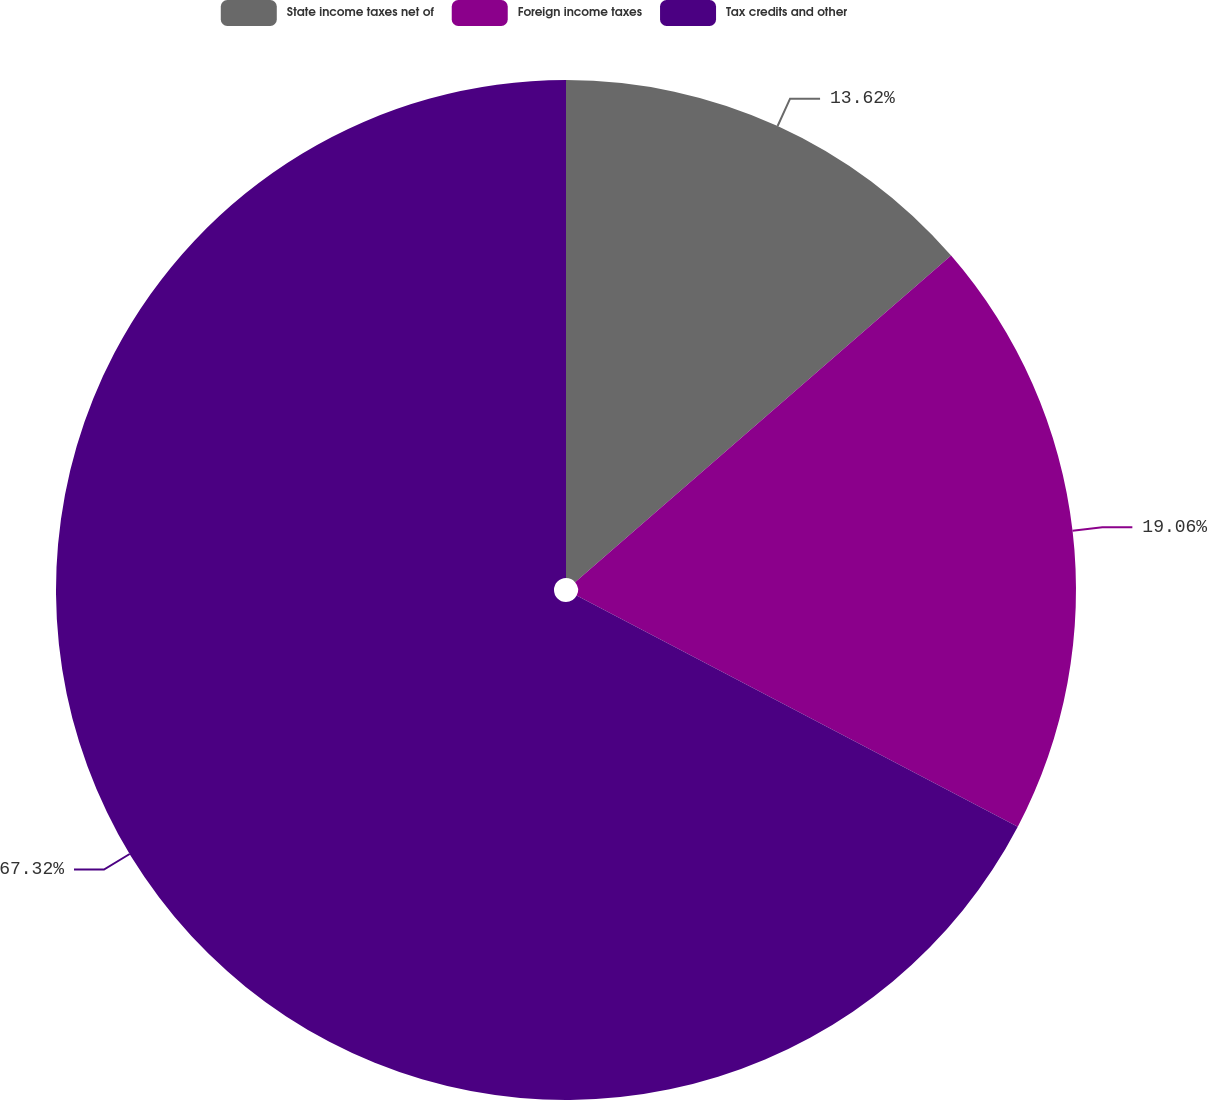Convert chart. <chart><loc_0><loc_0><loc_500><loc_500><pie_chart><fcel>State income taxes net of<fcel>Foreign income taxes<fcel>Tax credits and other<nl><fcel>13.62%<fcel>19.06%<fcel>67.32%<nl></chart> 